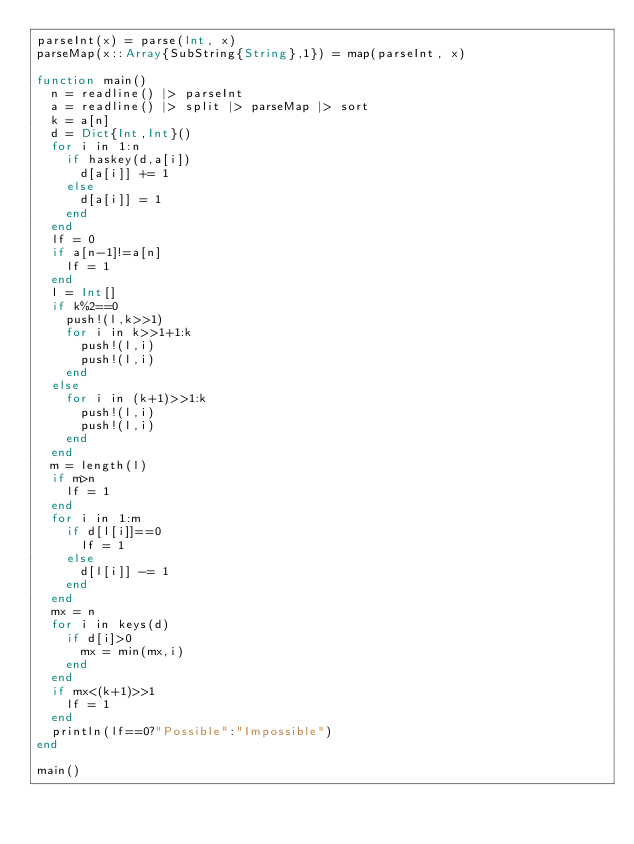Convert code to text. <code><loc_0><loc_0><loc_500><loc_500><_Julia_>parseInt(x) = parse(Int, x)
parseMap(x::Array{SubString{String},1}) = map(parseInt, x)

function main()
	n = readline() |> parseInt
	a = readline() |> split |> parseMap |> sort
	k = a[n]
	d = Dict{Int,Int}()
	for i in 1:n
		if haskey(d,a[i])
			d[a[i]] += 1
		else
			d[a[i]] = 1
		end
	end
	lf = 0
	if a[n-1]!=a[n]
		lf = 1
	end
	l = Int[]
	if k%2==0
		push!(l,k>>1)
		for i in k>>1+1:k
			push!(l,i)
			push!(l,i)
		end
	else
		for i in (k+1)>>1:k
			push!(l,i)
			push!(l,i)
		end
	end
	m = length(l)
	if m>n
		lf = 1
	end
	for i in 1:m
		if d[l[i]]==0
			lf = 1
		else
			d[l[i]] -= 1
		end
	end
	mx = n
	for i in keys(d)
		if d[i]>0
			mx = min(mx,i)
		end
	end
	if mx<(k+1)>>1
		lf = 1
	end
	println(lf==0?"Possible":"Impossible")
end

main()</code> 